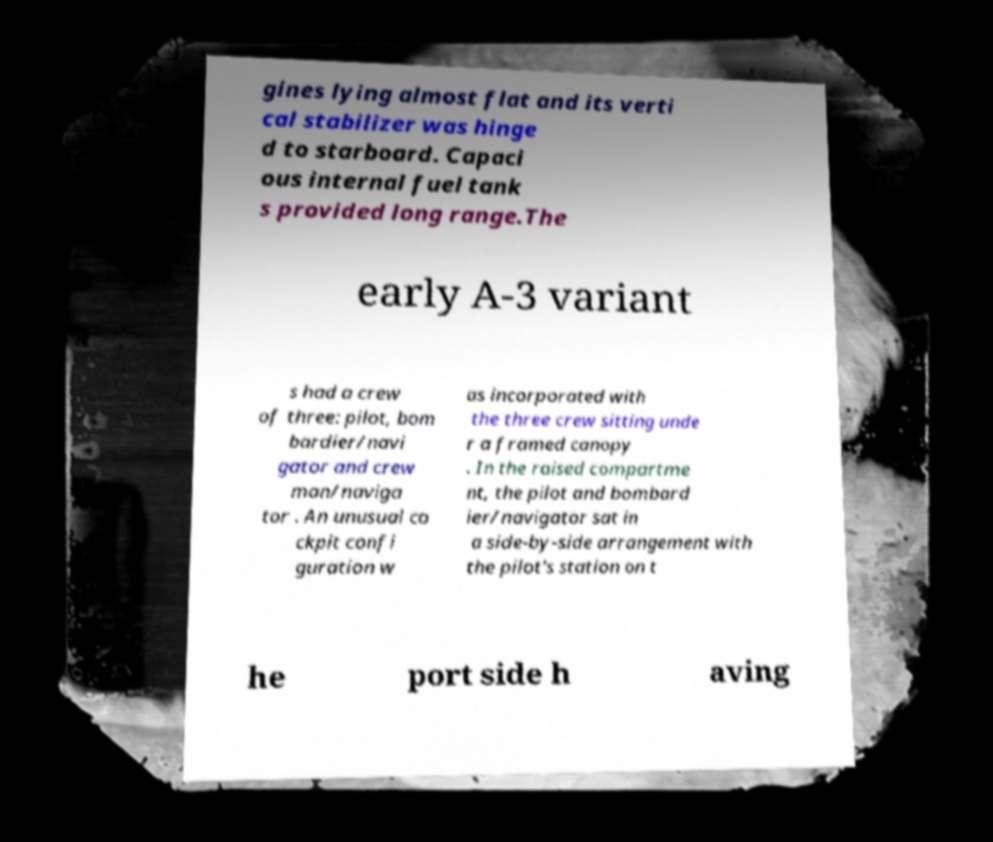I need the written content from this picture converted into text. Can you do that? gines lying almost flat and its verti cal stabilizer was hinge d to starboard. Capaci ous internal fuel tank s provided long range.The early A-3 variant s had a crew of three: pilot, bom bardier/navi gator and crew man/naviga tor . An unusual co ckpit confi guration w as incorporated with the three crew sitting unde r a framed canopy . In the raised compartme nt, the pilot and bombard ier/navigator sat in a side-by-side arrangement with the pilot's station on t he port side h aving 